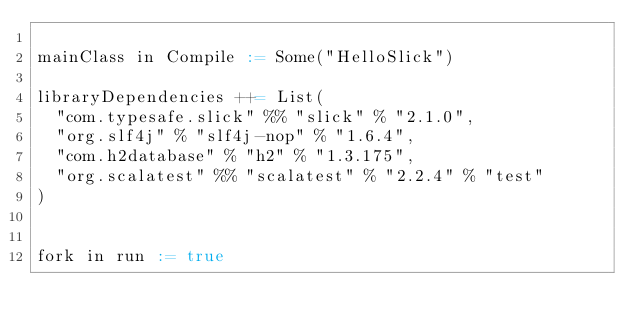Convert code to text. <code><loc_0><loc_0><loc_500><loc_500><_Scala_>
mainClass in Compile := Some("HelloSlick")

libraryDependencies ++= List(
  "com.typesafe.slick" %% "slick" % "2.1.0",
  "org.slf4j" % "slf4j-nop" % "1.6.4",
  "com.h2database" % "h2" % "1.3.175",
  "org.scalatest" %% "scalatest" % "2.2.4" % "test"
)


fork in run := true</code> 